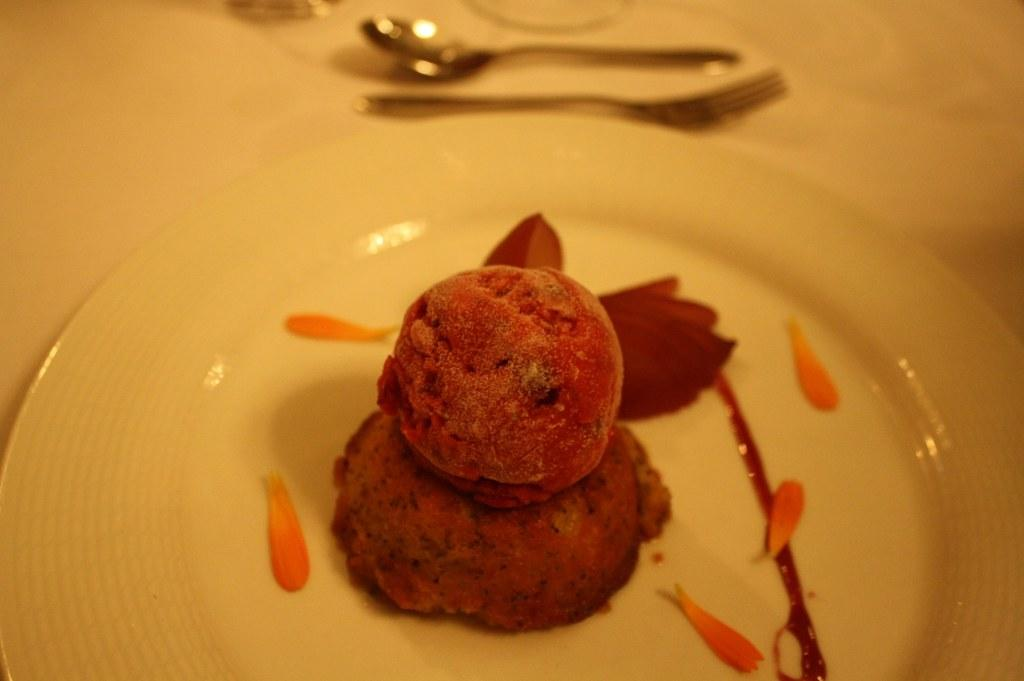What is the main food item visible on the plate in the image? The specific food item is not mentioned, but there is a food item on a plate in the image. What utensils are visible in the image? A spoon and a fork are visible at the top of the image. What can be inferred about the setting of the image? The presence of a plate and utensils suggests that the image likely depicts a table setting. What type of crook is sitting at the table in the image? There is no crook present in the image; it depicts a table setting with a food item on a plate and utensils. How many oranges are on the plate in the image? There is no mention of oranges in the image; the specific food item on the plate is not described. 